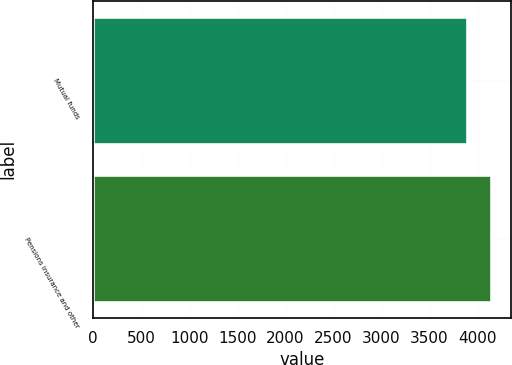Convert chart. <chart><loc_0><loc_0><loc_500><loc_500><bar_chart><fcel>Mutual funds<fcel>Pensions insurance and other<nl><fcel>3891<fcel>4136<nl></chart> 